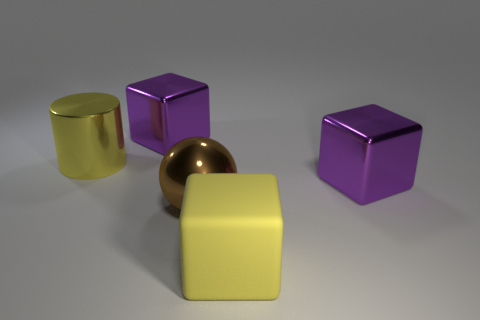If the purple cube and the yellow cylinder weigh the same, which one would you say takes up more space? Given that the purple cube looks substantially larger than the yellow cylinder, it would occupy more space, despite their weights being the same. 